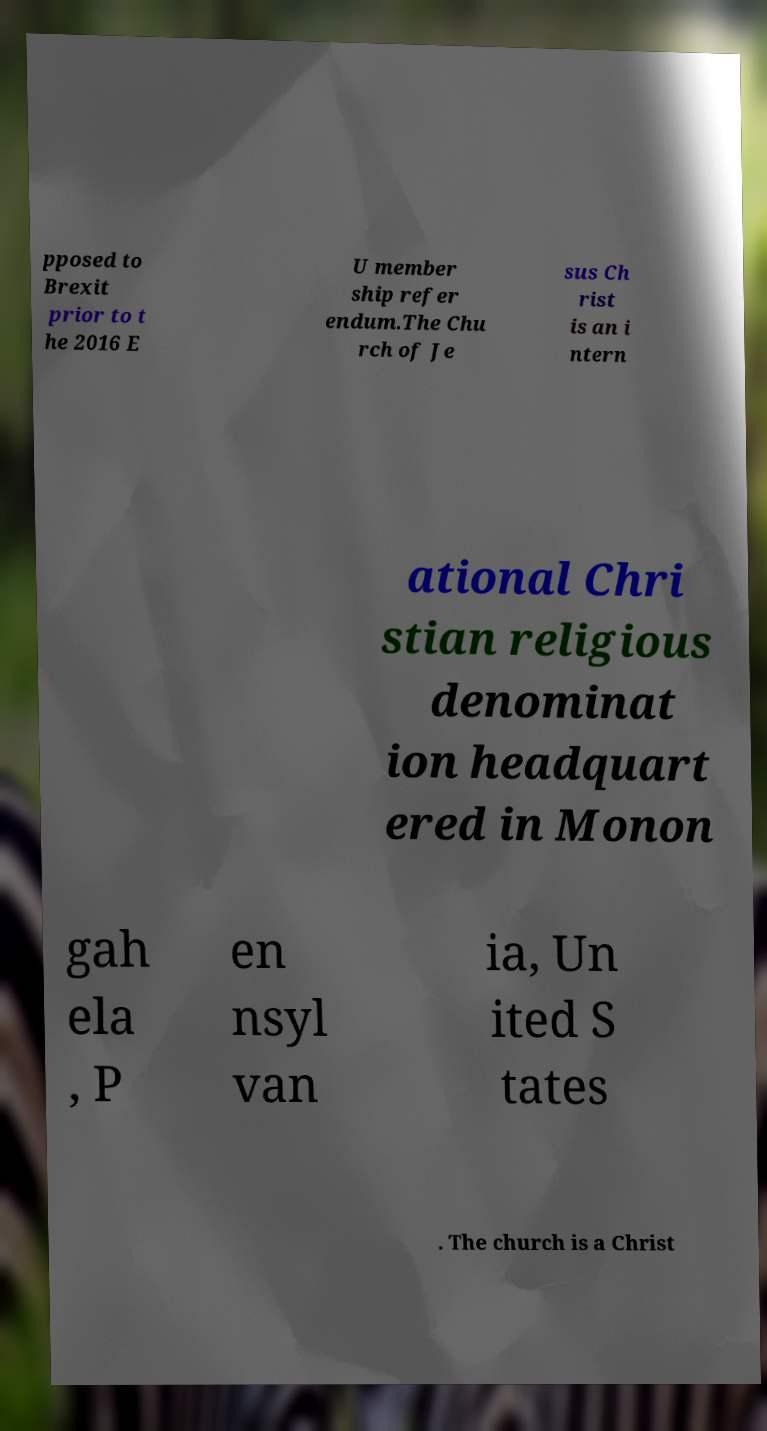Can you read and provide the text displayed in the image?This photo seems to have some interesting text. Can you extract and type it out for me? pposed to Brexit prior to t he 2016 E U member ship refer endum.The Chu rch of Je sus Ch rist is an i ntern ational Chri stian religious denominat ion headquart ered in Monon gah ela , P en nsyl van ia, Un ited S tates . The church is a Christ 